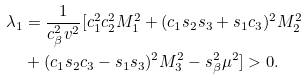<formula> <loc_0><loc_0><loc_500><loc_500>\lambda _ { 1 } & = \frac { 1 } { c _ { \beta } ^ { 2 } v ^ { 2 } } [ c _ { 1 } ^ { 2 } c _ { 2 } ^ { 2 } M _ { 1 } ^ { 2 } + ( c _ { 1 } s _ { 2 } s _ { 3 } + s _ { 1 } c _ { 3 } ) ^ { 2 } M _ { 2 } ^ { 2 } \\ & + ( c _ { 1 } s _ { 2 } c _ { 3 } - s _ { 1 } s _ { 3 } ) ^ { 2 } M _ { 3 } ^ { 2 } - s _ { \beta } ^ { 2 } \mu ^ { 2 } ] > 0 .</formula> 